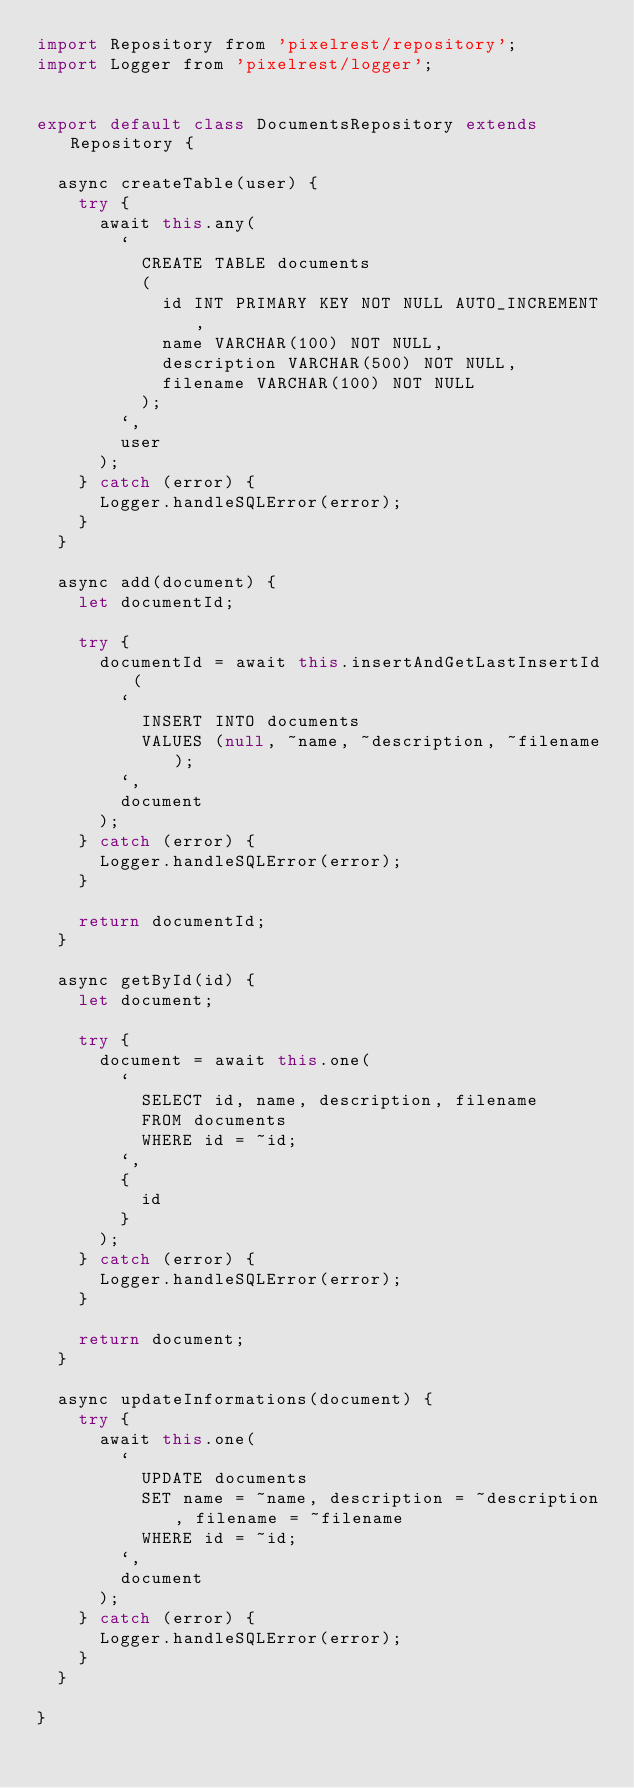Convert code to text. <code><loc_0><loc_0><loc_500><loc_500><_JavaScript_>import Repository from 'pixelrest/repository';
import Logger from 'pixelrest/logger';


export default class DocumentsRepository extends Repository {

  async createTable(user) {
    try {
      await this.any(
        `
          CREATE TABLE documents
          (
            id INT PRIMARY KEY NOT NULL AUTO_INCREMENT,
            name VARCHAR(100) NOT NULL,
            description VARCHAR(500) NOT NULL,
            filename VARCHAR(100) NOT NULL
          );
        `,
        user
      );
    } catch (error) {
      Logger.handleSQLError(error);
    }
  }

  async add(document) {
    let documentId;

    try {
      documentId = await this.insertAndGetLastInsertId(
        `
          INSERT INTO documents
          VALUES (null, ~name, ~description, ~filename);
        `,
        document
      );
    } catch (error) {
      Logger.handleSQLError(error);
    }

    return documentId;
  }

  async getById(id) {
    let document;

    try {
      document = await this.one(
        `
          SELECT id, name, description, filename
          FROM documents
          WHERE id = ~id;
        `,
        {
          id
        }
      );
    } catch (error) {
      Logger.handleSQLError(error);
    }

    return document;
  }

  async updateInformations(document) {
    try {
      await this.one(
        `
          UPDATE documents 
          SET name = ~name, description = ~description, filename = ~filename 
          WHERE id = ~id;
        `,
        document
      );
    } catch (error) {
      Logger.handleSQLError(error);
    }
  }

}
</code> 